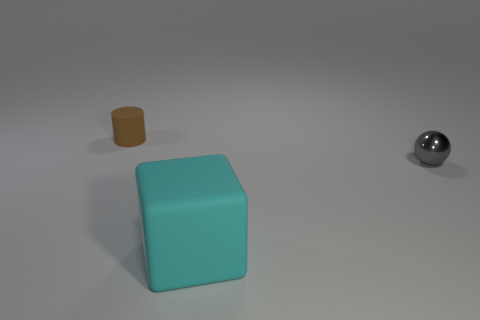Are there any other things that are the same size as the cyan block?
Ensure brevity in your answer.  No. There is a big matte block; are there any things behind it?
Keep it short and to the point. Yes. What color is the ball that is the same size as the brown matte cylinder?
Ensure brevity in your answer.  Gray. How many things are either small things that are in front of the cylinder or gray shiny spheres?
Give a very brief answer. 1. There is a object that is both to the left of the gray shiny sphere and behind the large cyan thing; what is its size?
Offer a very short reply. Small. What number of other things are the same size as the cube?
Give a very brief answer. 0. What color is the thing to the right of the thing in front of the thing to the right of the big cyan rubber block?
Provide a succinct answer. Gray. What is the shape of the object that is both to the left of the gray metal sphere and in front of the tiny matte object?
Your answer should be compact. Cube. How many other things are the same shape as the big thing?
Your answer should be compact. 0. What is the shape of the object in front of the small thing in front of the matte object that is behind the cyan object?
Give a very brief answer. Cube. 